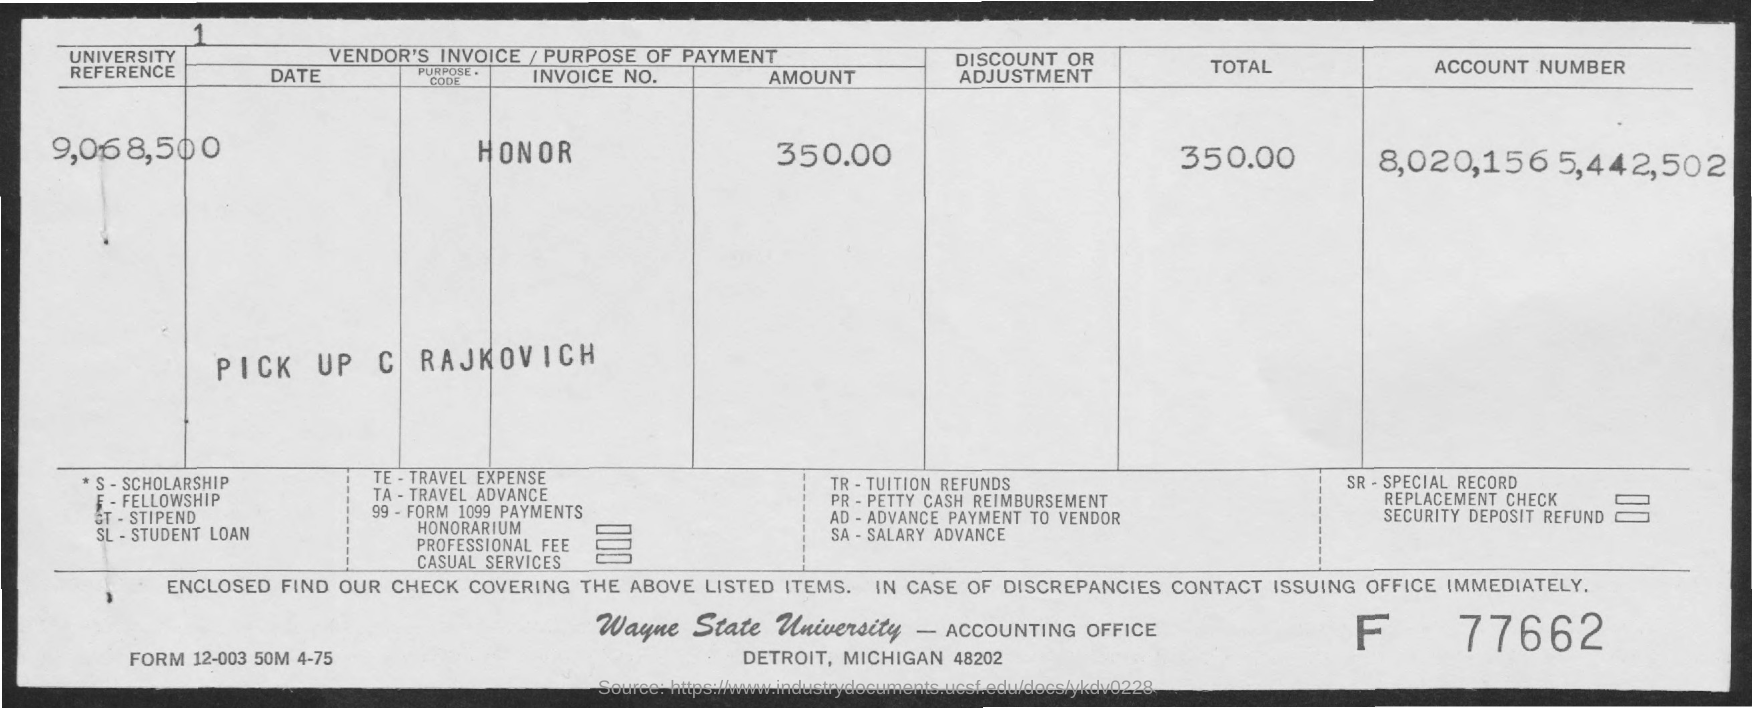What is the Fullform for TE ?
Ensure brevity in your answer.  TRAVEL EXPENSE. What is the Account Number ?
Your answer should be very brief. 8,020,1565,442,502. What is the Fullform of SA ?
Your answer should be very brief. Salary advance. How much total amount ?
Offer a very short reply. 350.00. What is the Fullform of SL ?
Your answer should be very brief. Student loan. What is the Fullform of TA ?
Make the answer very short. TRAVEL ADVANCE. 